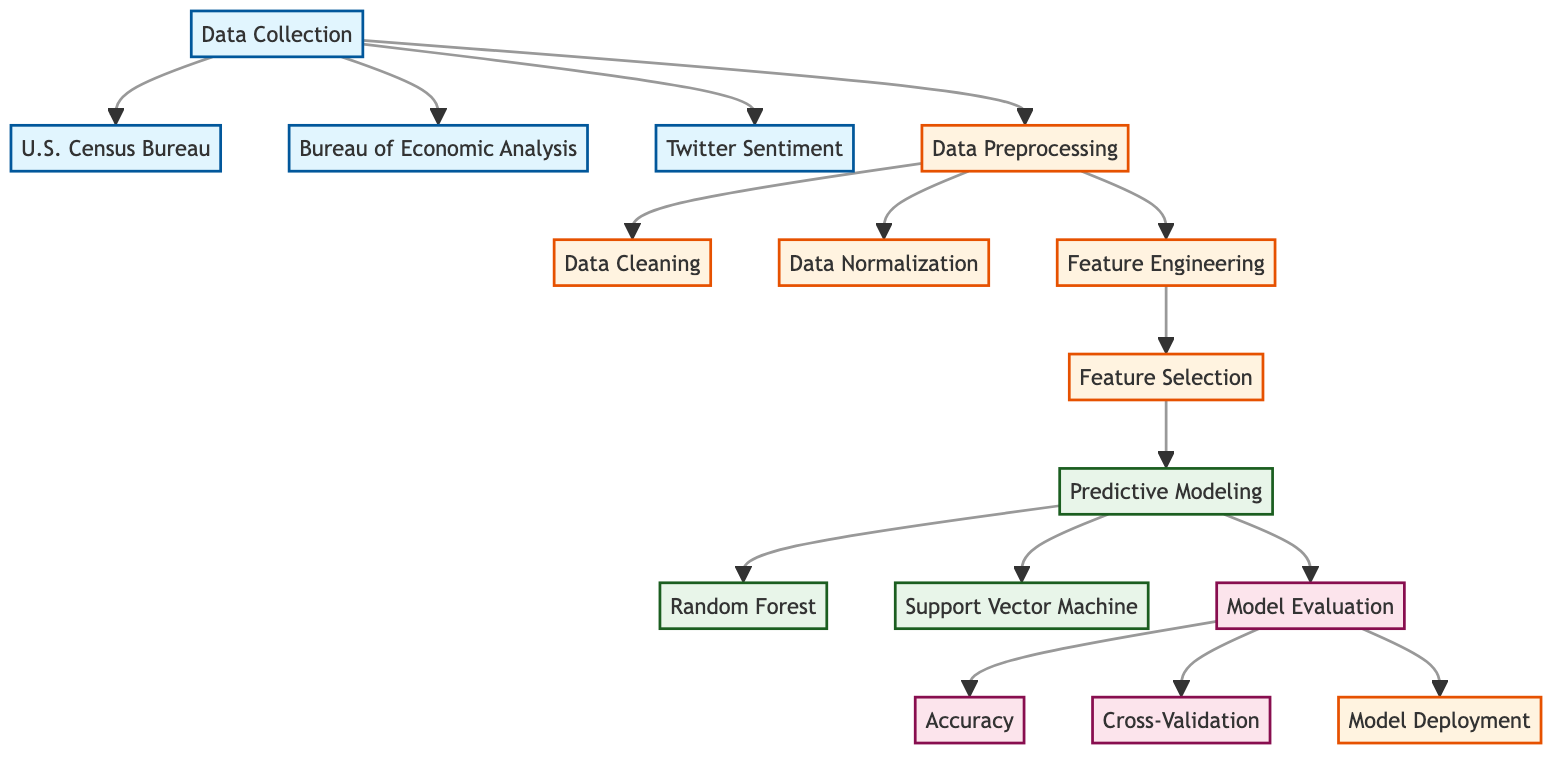What is the first step in the predictive modeling process? The first step in the process is "Data Collection," which is the starting point in the flowchart indicating the acquisition of relevant data.
Answer: Data Collection How many data sources are used for data collection? The diagram shows three sources being collected: U.S. Census Bureau, Bureau of Economic Analysis, and Twitter Sentiment. Therefore, there are three sources in total.
Answer: Three What step comes after feature engineering? After feature engineering, the next step in the flowchart is "Feature Selection," which is where significant features are chosen for building the predictive model.
Answer: Feature Selection What are the two predictive modeling approaches mentioned in the diagram? The diagram indicates two techniques: "Random Forest" and "Support Vector Machine," both under the predictive modeling process, representing different modeling strategies.
Answer: Random Forest and Support Vector Machine What evaluation method is specifically mentioned alongside accuracy? The evaluation method shown alongside accuracy is "Cross-Validation," which often helps in assessing how the results of the model will generalize to an independent data set.
Answer: Cross-Validation Explain the relationship between feature selection and predictive modeling. Feature selection is a preceding step to predictive modeling. Once features are selected based on their significance, predictive modeling can commence to build the actual models using these features.
Answer: Feature selection precedes predictive modeling What is the last process shown before model deployment? The last process depicted before deployment is "Model Evaluation," which assesses the model performance using defined metrics like accuracy and cross-validation, ensuring the model's readiness for deployment.
Answer: Model Evaluation How many processes are involved in data preprocessing? The diagram illustrates three key processes under data preprocessing: Data Cleaning, Data Normalization, and Feature Engineering. Therefore, there are three processes in total.
Answer: Three 